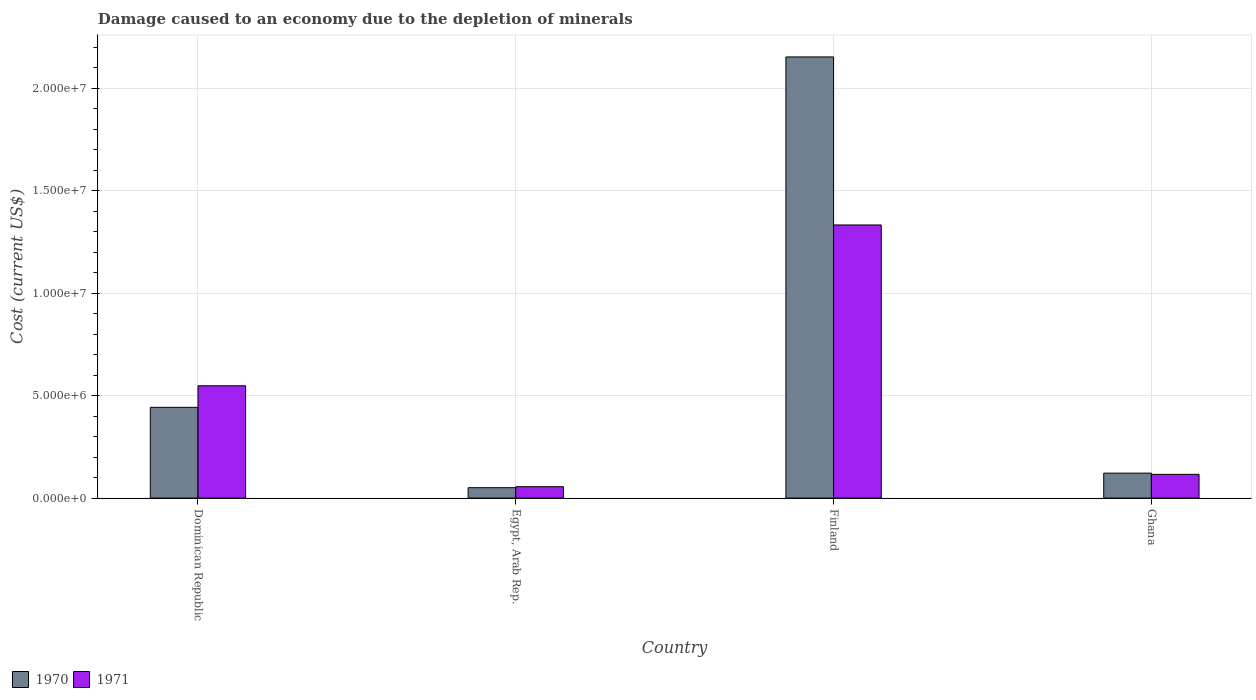How many groups of bars are there?
Provide a short and direct response. 4. Are the number of bars per tick equal to the number of legend labels?
Your response must be concise. Yes. Are the number of bars on each tick of the X-axis equal?
Ensure brevity in your answer.  Yes. How many bars are there on the 1st tick from the left?
Provide a succinct answer. 2. How many bars are there on the 2nd tick from the right?
Ensure brevity in your answer.  2. What is the label of the 3rd group of bars from the left?
Your answer should be compact. Finland. In how many cases, is the number of bars for a given country not equal to the number of legend labels?
Ensure brevity in your answer.  0. What is the cost of damage caused due to the depletion of minerals in 1971 in Ghana?
Your answer should be very brief. 1.16e+06. Across all countries, what is the maximum cost of damage caused due to the depletion of minerals in 1970?
Offer a very short reply. 2.15e+07. Across all countries, what is the minimum cost of damage caused due to the depletion of minerals in 1971?
Offer a very short reply. 5.55e+05. In which country was the cost of damage caused due to the depletion of minerals in 1971 minimum?
Make the answer very short. Egypt, Arab Rep. What is the total cost of damage caused due to the depletion of minerals in 1970 in the graph?
Give a very brief answer. 2.77e+07. What is the difference between the cost of damage caused due to the depletion of minerals in 1971 in Finland and that in Ghana?
Ensure brevity in your answer.  1.22e+07. What is the difference between the cost of damage caused due to the depletion of minerals in 1970 in Ghana and the cost of damage caused due to the depletion of minerals in 1971 in Egypt, Arab Rep.?
Your answer should be compact. 6.62e+05. What is the average cost of damage caused due to the depletion of minerals in 1970 per country?
Give a very brief answer. 6.92e+06. What is the difference between the cost of damage caused due to the depletion of minerals of/in 1971 and cost of damage caused due to the depletion of minerals of/in 1970 in Egypt, Arab Rep.?
Offer a terse response. 4.79e+04. In how many countries, is the cost of damage caused due to the depletion of minerals in 1970 greater than 10000000 US$?
Make the answer very short. 1. What is the ratio of the cost of damage caused due to the depletion of minerals in 1971 in Finland to that in Ghana?
Your answer should be compact. 11.5. What is the difference between the highest and the second highest cost of damage caused due to the depletion of minerals in 1971?
Offer a very short reply. 1.22e+07. What is the difference between the highest and the lowest cost of damage caused due to the depletion of minerals in 1971?
Provide a succinct answer. 1.28e+07. In how many countries, is the cost of damage caused due to the depletion of minerals in 1971 greater than the average cost of damage caused due to the depletion of minerals in 1971 taken over all countries?
Provide a succinct answer. 2. What does the 2nd bar from the left in Dominican Republic represents?
Your answer should be compact. 1971. How many bars are there?
Give a very brief answer. 8. Are all the bars in the graph horizontal?
Your answer should be compact. No. How many countries are there in the graph?
Your answer should be compact. 4. What is the difference between two consecutive major ticks on the Y-axis?
Keep it short and to the point. 5.00e+06. Does the graph contain any zero values?
Provide a short and direct response. No. Does the graph contain grids?
Offer a terse response. Yes. How many legend labels are there?
Give a very brief answer. 2. How are the legend labels stacked?
Make the answer very short. Horizontal. What is the title of the graph?
Offer a very short reply. Damage caused to an economy due to the depletion of minerals. What is the label or title of the Y-axis?
Your answer should be very brief. Cost (current US$). What is the Cost (current US$) of 1970 in Dominican Republic?
Keep it short and to the point. 4.43e+06. What is the Cost (current US$) of 1971 in Dominican Republic?
Give a very brief answer. 5.48e+06. What is the Cost (current US$) of 1970 in Egypt, Arab Rep.?
Make the answer very short. 5.07e+05. What is the Cost (current US$) in 1971 in Egypt, Arab Rep.?
Your response must be concise. 5.55e+05. What is the Cost (current US$) in 1970 in Finland?
Ensure brevity in your answer.  2.15e+07. What is the Cost (current US$) in 1971 in Finland?
Keep it short and to the point. 1.33e+07. What is the Cost (current US$) of 1970 in Ghana?
Offer a very short reply. 1.22e+06. What is the Cost (current US$) of 1971 in Ghana?
Offer a terse response. 1.16e+06. Across all countries, what is the maximum Cost (current US$) in 1970?
Provide a short and direct response. 2.15e+07. Across all countries, what is the maximum Cost (current US$) in 1971?
Ensure brevity in your answer.  1.33e+07. Across all countries, what is the minimum Cost (current US$) of 1970?
Your response must be concise. 5.07e+05. Across all countries, what is the minimum Cost (current US$) of 1971?
Ensure brevity in your answer.  5.55e+05. What is the total Cost (current US$) of 1970 in the graph?
Provide a short and direct response. 2.77e+07. What is the total Cost (current US$) in 1971 in the graph?
Offer a very short reply. 2.05e+07. What is the difference between the Cost (current US$) in 1970 in Dominican Republic and that in Egypt, Arab Rep.?
Provide a short and direct response. 3.92e+06. What is the difference between the Cost (current US$) of 1971 in Dominican Republic and that in Egypt, Arab Rep.?
Offer a terse response. 4.92e+06. What is the difference between the Cost (current US$) of 1970 in Dominican Republic and that in Finland?
Your response must be concise. -1.71e+07. What is the difference between the Cost (current US$) in 1971 in Dominican Republic and that in Finland?
Provide a short and direct response. -7.85e+06. What is the difference between the Cost (current US$) in 1970 in Dominican Republic and that in Ghana?
Give a very brief answer. 3.21e+06. What is the difference between the Cost (current US$) in 1971 in Dominican Republic and that in Ghana?
Your response must be concise. 4.32e+06. What is the difference between the Cost (current US$) in 1970 in Egypt, Arab Rep. and that in Finland?
Give a very brief answer. -2.10e+07. What is the difference between the Cost (current US$) in 1971 in Egypt, Arab Rep. and that in Finland?
Keep it short and to the point. -1.28e+07. What is the difference between the Cost (current US$) of 1970 in Egypt, Arab Rep. and that in Ghana?
Provide a short and direct response. -7.10e+05. What is the difference between the Cost (current US$) of 1971 in Egypt, Arab Rep. and that in Ghana?
Your response must be concise. -6.03e+05. What is the difference between the Cost (current US$) in 1970 in Finland and that in Ghana?
Keep it short and to the point. 2.03e+07. What is the difference between the Cost (current US$) of 1971 in Finland and that in Ghana?
Your answer should be very brief. 1.22e+07. What is the difference between the Cost (current US$) in 1970 in Dominican Republic and the Cost (current US$) in 1971 in Egypt, Arab Rep.?
Keep it short and to the point. 3.87e+06. What is the difference between the Cost (current US$) in 1970 in Dominican Republic and the Cost (current US$) in 1971 in Finland?
Your answer should be very brief. -8.90e+06. What is the difference between the Cost (current US$) of 1970 in Dominican Republic and the Cost (current US$) of 1971 in Ghana?
Make the answer very short. 3.27e+06. What is the difference between the Cost (current US$) of 1970 in Egypt, Arab Rep. and the Cost (current US$) of 1971 in Finland?
Keep it short and to the point. -1.28e+07. What is the difference between the Cost (current US$) of 1970 in Egypt, Arab Rep. and the Cost (current US$) of 1971 in Ghana?
Keep it short and to the point. -6.51e+05. What is the difference between the Cost (current US$) in 1970 in Finland and the Cost (current US$) in 1971 in Ghana?
Provide a short and direct response. 2.04e+07. What is the average Cost (current US$) of 1970 per country?
Ensure brevity in your answer.  6.92e+06. What is the average Cost (current US$) in 1971 per country?
Your answer should be compact. 5.13e+06. What is the difference between the Cost (current US$) of 1970 and Cost (current US$) of 1971 in Dominican Republic?
Your answer should be very brief. -1.05e+06. What is the difference between the Cost (current US$) in 1970 and Cost (current US$) in 1971 in Egypt, Arab Rep.?
Offer a terse response. -4.79e+04. What is the difference between the Cost (current US$) of 1970 and Cost (current US$) of 1971 in Finland?
Your answer should be very brief. 8.20e+06. What is the difference between the Cost (current US$) of 1970 and Cost (current US$) of 1971 in Ghana?
Keep it short and to the point. 5.86e+04. What is the ratio of the Cost (current US$) of 1970 in Dominican Republic to that in Egypt, Arab Rep.?
Your answer should be compact. 8.73. What is the ratio of the Cost (current US$) in 1971 in Dominican Republic to that in Egypt, Arab Rep.?
Your answer should be compact. 9.87. What is the ratio of the Cost (current US$) of 1970 in Dominican Republic to that in Finland?
Provide a succinct answer. 0.21. What is the ratio of the Cost (current US$) in 1971 in Dominican Republic to that in Finland?
Your response must be concise. 0.41. What is the ratio of the Cost (current US$) of 1970 in Dominican Republic to that in Ghana?
Provide a succinct answer. 3.64. What is the ratio of the Cost (current US$) in 1971 in Dominican Republic to that in Ghana?
Your answer should be very brief. 4.73. What is the ratio of the Cost (current US$) of 1970 in Egypt, Arab Rep. to that in Finland?
Give a very brief answer. 0.02. What is the ratio of the Cost (current US$) of 1971 in Egypt, Arab Rep. to that in Finland?
Offer a very short reply. 0.04. What is the ratio of the Cost (current US$) in 1970 in Egypt, Arab Rep. to that in Ghana?
Offer a terse response. 0.42. What is the ratio of the Cost (current US$) in 1971 in Egypt, Arab Rep. to that in Ghana?
Your answer should be compact. 0.48. What is the ratio of the Cost (current US$) in 1970 in Finland to that in Ghana?
Make the answer very short. 17.68. What is the ratio of the Cost (current US$) in 1971 in Finland to that in Ghana?
Ensure brevity in your answer.  11.5. What is the difference between the highest and the second highest Cost (current US$) in 1970?
Offer a terse response. 1.71e+07. What is the difference between the highest and the second highest Cost (current US$) of 1971?
Your answer should be very brief. 7.85e+06. What is the difference between the highest and the lowest Cost (current US$) of 1970?
Your response must be concise. 2.10e+07. What is the difference between the highest and the lowest Cost (current US$) in 1971?
Ensure brevity in your answer.  1.28e+07. 